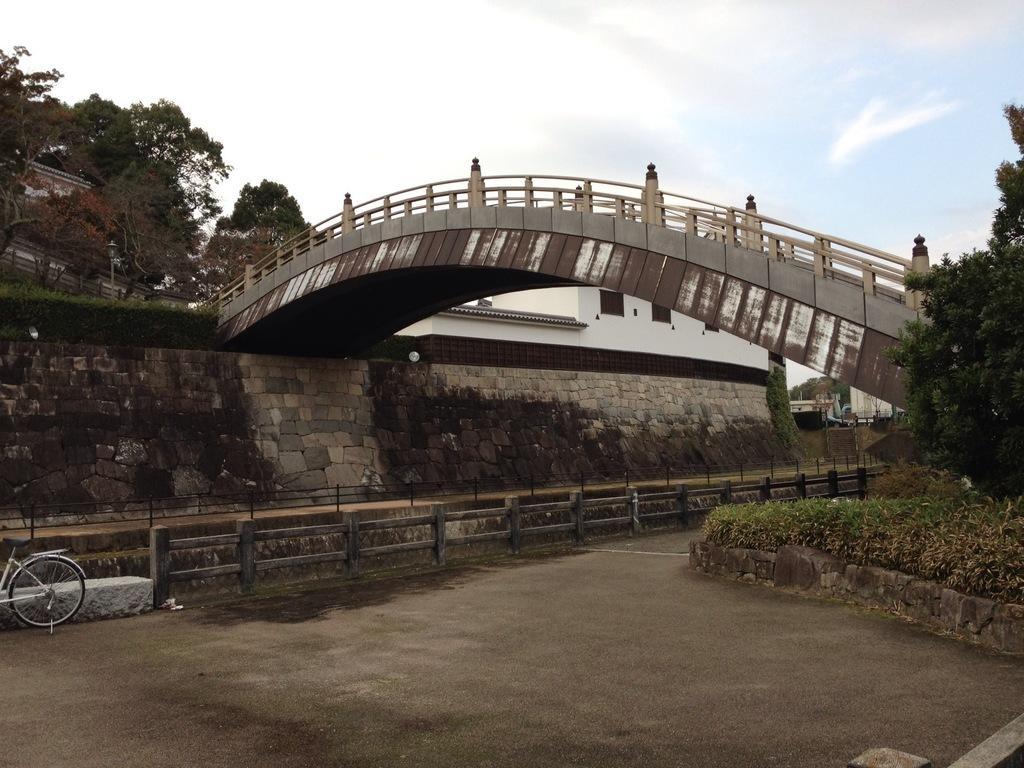Describe this image in one or two sentences. In this picture there is a bridge. On the left there is a bicycle which is parked near to the wooden fencing and stone wall. In the top left there is a building, beside that we can see many trees. At the top we can see sky and clouds. On the right we can see the plants. 